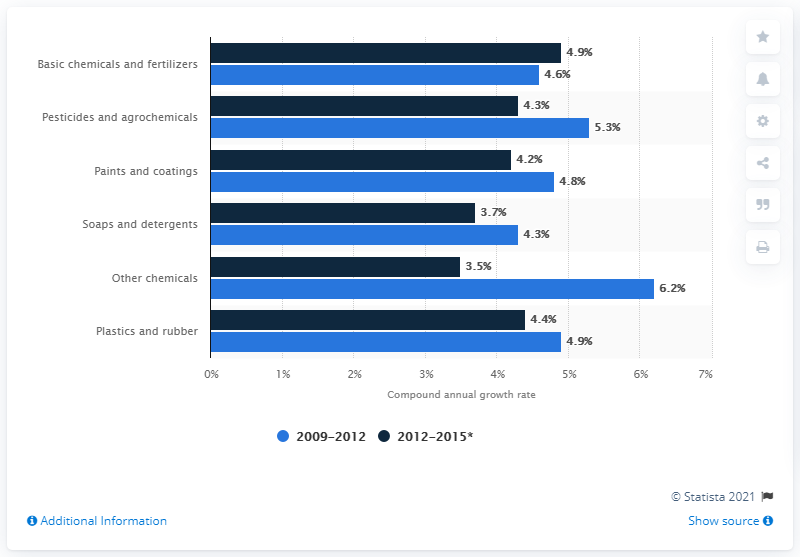Mention a couple of crucial points in this snapshot. The inorganic chemical industry is expected to grow at a compound annual growth rate (CAGR) of approximately 3.5% over the next five years. 